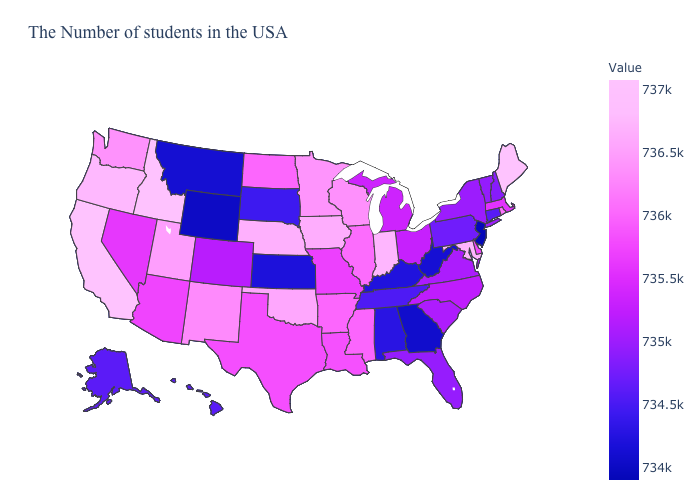Among the states that border South Dakota , which have the lowest value?
Answer briefly. Wyoming. Does California have the highest value in the West?
Keep it brief. Yes. Does New Jersey have the lowest value in the USA?
Answer briefly. Yes. Does Colorado have the lowest value in the West?
Be succinct. No. 